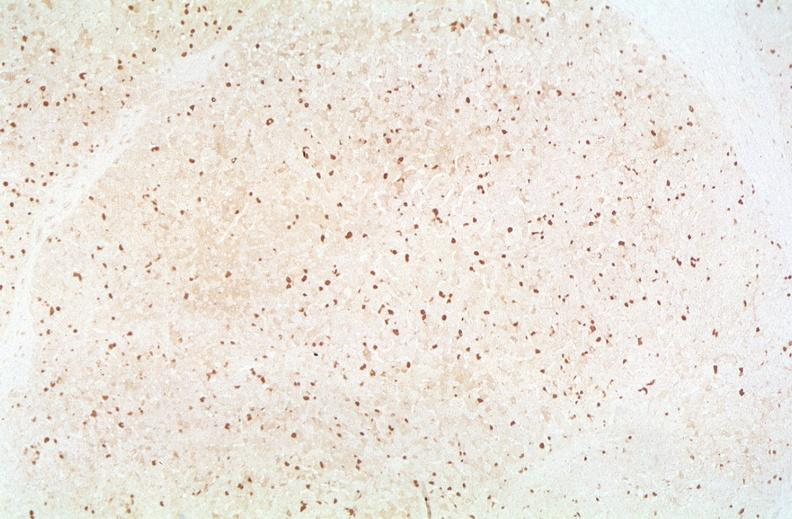what does this image show?
Answer the question using a single word or phrase. Hepatitis b virus 